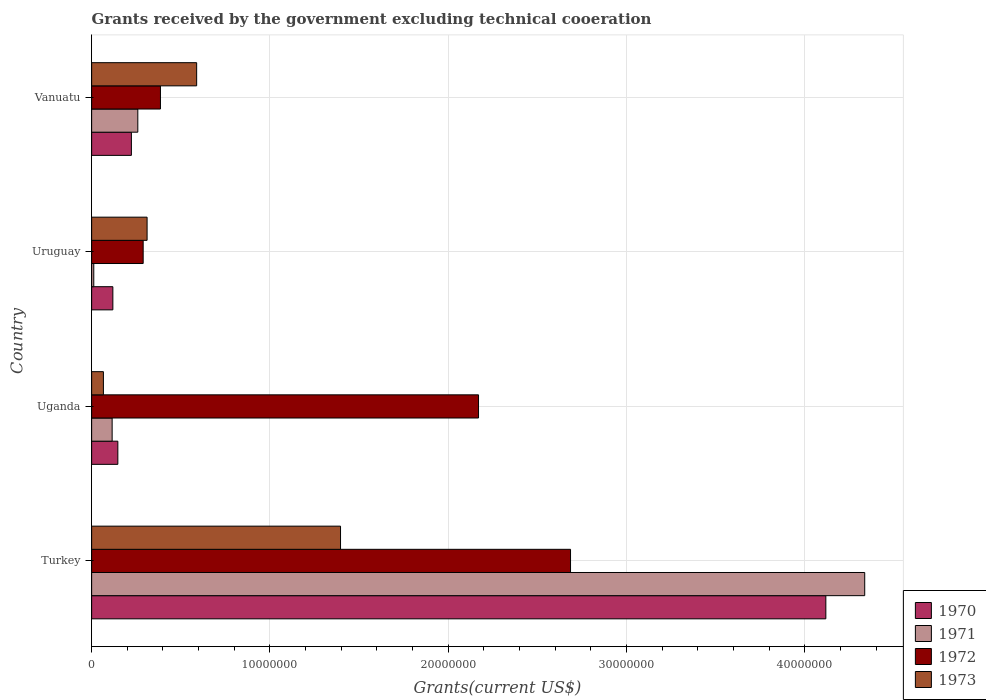How many groups of bars are there?
Offer a very short reply. 4. Are the number of bars per tick equal to the number of legend labels?
Offer a very short reply. Yes. How many bars are there on the 2nd tick from the top?
Your answer should be very brief. 4. In how many cases, is the number of bars for a given country not equal to the number of legend labels?
Give a very brief answer. 0. What is the total grants received by the government in 1973 in Vanuatu?
Keep it short and to the point. 5.89e+06. Across all countries, what is the maximum total grants received by the government in 1971?
Your answer should be compact. 4.34e+07. Across all countries, what is the minimum total grants received by the government in 1970?
Offer a very short reply. 1.19e+06. In which country was the total grants received by the government in 1972 minimum?
Your answer should be very brief. Uruguay. What is the total total grants received by the government in 1973 in the graph?
Provide a short and direct response. 2.36e+07. What is the difference between the total grants received by the government in 1971 in Turkey and that in Uganda?
Provide a short and direct response. 4.22e+07. What is the difference between the total grants received by the government in 1972 in Turkey and the total grants received by the government in 1970 in Vanuatu?
Offer a very short reply. 2.46e+07. What is the average total grants received by the government in 1970 per country?
Ensure brevity in your answer.  1.15e+07. What is the difference between the total grants received by the government in 1972 and total grants received by the government in 1970 in Vanuatu?
Provide a succinct answer. 1.63e+06. In how many countries, is the total grants received by the government in 1973 greater than 40000000 US$?
Provide a succinct answer. 0. What is the ratio of the total grants received by the government in 1973 in Uruguay to that in Vanuatu?
Provide a succinct answer. 0.53. Is the difference between the total grants received by the government in 1972 in Uganda and Vanuatu greater than the difference between the total grants received by the government in 1970 in Uganda and Vanuatu?
Provide a short and direct response. Yes. What is the difference between the highest and the second highest total grants received by the government in 1973?
Keep it short and to the point. 8.07e+06. What is the difference between the highest and the lowest total grants received by the government in 1970?
Offer a very short reply. 4.00e+07. In how many countries, is the total grants received by the government in 1973 greater than the average total grants received by the government in 1973 taken over all countries?
Offer a terse response. 1. Is the sum of the total grants received by the government in 1970 in Uganda and Vanuatu greater than the maximum total grants received by the government in 1971 across all countries?
Offer a terse response. No. What does the 2nd bar from the top in Turkey represents?
Offer a terse response. 1972. Is it the case that in every country, the sum of the total grants received by the government in 1971 and total grants received by the government in 1970 is greater than the total grants received by the government in 1972?
Keep it short and to the point. No. What is the difference between two consecutive major ticks on the X-axis?
Ensure brevity in your answer.  1.00e+07. Where does the legend appear in the graph?
Your response must be concise. Bottom right. How many legend labels are there?
Make the answer very short. 4. How are the legend labels stacked?
Offer a terse response. Vertical. What is the title of the graph?
Keep it short and to the point. Grants received by the government excluding technical cooeration. What is the label or title of the X-axis?
Offer a very short reply. Grants(current US$). What is the label or title of the Y-axis?
Your response must be concise. Country. What is the Grants(current US$) of 1970 in Turkey?
Offer a very short reply. 4.12e+07. What is the Grants(current US$) of 1971 in Turkey?
Your answer should be very brief. 4.34e+07. What is the Grants(current US$) in 1972 in Turkey?
Provide a succinct answer. 2.69e+07. What is the Grants(current US$) in 1973 in Turkey?
Provide a short and direct response. 1.40e+07. What is the Grants(current US$) in 1970 in Uganda?
Your response must be concise. 1.47e+06. What is the Grants(current US$) in 1971 in Uganda?
Ensure brevity in your answer.  1.15e+06. What is the Grants(current US$) of 1972 in Uganda?
Your response must be concise. 2.17e+07. What is the Grants(current US$) of 1973 in Uganda?
Offer a terse response. 6.60e+05. What is the Grants(current US$) in 1970 in Uruguay?
Ensure brevity in your answer.  1.19e+06. What is the Grants(current US$) in 1972 in Uruguay?
Your answer should be compact. 2.89e+06. What is the Grants(current US$) of 1973 in Uruguay?
Make the answer very short. 3.11e+06. What is the Grants(current US$) in 1970 in Vanuatu?
Make the answer very short. 2.23e+06. What is the Grants(current US$) in 1971 in Vanuatu?
Make the answer very short. 2.59e+06. What is the Grants(current US$) in 1972 in Vanuatu?
Make the answer very short. 3.86e+06. What is the Grants(current US$) in 1973 in Vanuatu?
Ensure brevity in your answer.  5.89e+06. Across all countries, what is the maximum Grants(current US$) of 1970?
Make the answer very short. 4.12e+07. Across all countries, what is the maximum Grants(current US$) in 1971?
Provide a succinct answer. 4.34e+07. Across all countries, what is the maximum Grants(current US$) of 1972?
Your answer should be very brief. 2.69e+07. Across all countries, what is the maximum Grants(current US$) in 1973?
Your answer should be compact. 1.40e+07. Across all countries, what is the minimum Grants(current US$) in 1970?
Your response must be concise. 1.19e+06. Across all countries, what is the minimum Grants(current US$) of 1972?
Your answer should be very brief. 2.89e+06. Across all countries, what is the minimum Grants(current US$) of 1973?
Offer a terse response. 6.60e+05. What is the total Grants(current US$) of 1970 in the graph?
Ensure brevity in your answer.  4.61e+07. What is the total Grants(current US$) of 1971 in the graph?
Your answer should be very brief. 4.72e+07. What is the total Grants(current US$) of 1972 in the graph?
Offer a very short reply. 5.53e+07. What is the total Grants(current US$) in 1973 in the graph?
Make the answer very short. 2.36e+07. What is the difference between the Grants(current US$) of 1970 in Turkey and that in Uganda?
Keep it short and to the point. 3.97e+07. What is the difference between the Grants(current US$) in 1971 in Turkey and that in Uganda?
Offer a terse response. 4.22e+07. What is the difference between the Grants(current US$) in 1972 in Turkey and that in Uganda?
Your answer should be very brief. 5.16e+06. What is the difference between the Grants(current US$) in 1973 in Turkey and that in Uganda?
Keep it short and to the point. 1.33e+07. What is the difference between the Grants(current US$) of 1970 in Turkey and that in Uruguay?
Your answer should be very brief. 4.00e+07. What is the difference between the Grants(current US$) of 1971 in Turkey and that in Uruguay?
Your answer should be compact. 4.32e+07. What is the difference between the Grants(current US$) in 1972 in Turkey and that in Uruguay?
Provide a short and direct response. 2.40e+07. What is the difference between the Grants(current US$) of 1973 in Turkey and that in Uruguay?
Your response must be concise. 1.08e+07. What is the difference between the Grants(current US$) of 1970 in Turkey and that in Vanuatu?
Your response must be concise. 3.90e+07. What is the difference between the Grants(current US$) of 1971 in Turkey and that in Vanuatu?
Your answer should be compact. 4.08e+07. What is the difference between the Grants(current US$) in 1972 in Turkey and that in Vanuatu?
Your answer should be compact. 2.30e+07. What is the difference between the Grants(current US$) in 1973 in Turkey and that in Vanuatu?
Keep it short and to the point. 8.07e+06. What is the difference between the Grants(current US$) of 1971 in Uganda and that in Uruguay?
Give a very brief answer. 1.03e+06. What is the difference between the Grants(current US$) of 1972 in Uganda and that in Uruguay?
Provide a succinct answer. 1.88e+07. What is the difference between the Grants(current US$) in 1973 in Uganda and that in Uruguay?
Provide a short and direct response. -2.45e+06. What is the difference between the Grants(current US$) of 1970 in Uganda and that in Vanuatu?
Provide a short and direct response. -7.60e+05. What is the difference between the Grants(current US$) in 1971 in Uganda and that in Vanuatu?
Keep it short and to the point. -1.44e+06. What is the difference between the Grants(current US$) in 1972 in Uganda and that in Vanuatu?
Make the answer very short. 1.78e+07. What is the difference between the Grants(current US$) of 1973 in Uganda and that in Vanuatu?
Offer a very short reply. -5.23e+06. What is the difference between the Grants(current US$) of 1970 in Uruguay and that in Vanuatu?
Provide a succinct answer. -1.04e+06. What is the difference between the Grants(current US$) in 1971 in Uruguay and that in Vanuatu?
Offer a very short reply. -2.47e+06. What is the difference between the Grants(current US$) of 1972 in Uruguay and that in Vanuatu?
Make the answer very short. -9.70e+05. What is the difference between the Grants(current US$) of 1973 in Uruguay and that in Vanuatu?
Provide a succinct answer. -2.78e+06. What is the difference between the Grants(current US$) of 1970 in Turkey and the Grants(current US$) of 1971 in Uganda?
Provide a short and direct response. 4.00e+07. What is the difference between the Grants(current US$) of 1970 in Turkey and the Grants(current US$) of 1972 in Uganda?
Ensure brevity in your answer.  1.95e+07. What is the difference between the Grants(current US$) in 1970 in Turkey and the Grants(current US$) in 1973 in Uganda?
Your response must be concise. 4.05e+07. What is the difference between the Grants(current US$) in 1971 in Turkey and the Grants(current US$) in 1972 in Uganda?
Provide a succinct answer. 2.17e+07. What is the difference between the Grants(current US$) in 1971 in Turkey and the Grants(current US$) in 1973 in Uganda?
Offer a very short reply. 4.27e+07. What is the difference between the Grants(current US$) in 1972 in Turkey and the Grants(current US$) in 1973 in Uganda?
Your answer should be very brief. 2.62e+07. What is the difference between the Grants(current US$) in 1970 in Turkey and the Grants(current US$) in 1971 in Uruguay?
Give a very brief answer. 4.11e+07. What is the difference between the Grants(current US$) in 1970 in Turkey and the Grants(current US$) in 1972 in Uruguay?
Your answer should be very brief. 3.83e+07. What is the difference between the Grants(current US$) in 1970 in Turkey and the Grants(current US$) in 1973 in Uruguay?
Offer a terse response. 3.81e+07. What is the difference between the Grants(current US$) of 1971 in Turkey and the Grants(current US$) of 1972 in Uruguay?
Provide a short and direct response. 4.05e+07. What is the difference between the Grants(current US$) of 1971 in Turkey and the Grants(current US$) of 1973 in Uruguay?
Ensure brevity in your answer.  4.02e+07. What is the difference between the Grants(current US$) of 1972 in Turkey and the Grants(current US$) of 1973 in Uruguay?
Offer a very short reply. 2.38e+07. What is the difference between the Grants(current US$) in 1970 in Turkey and the Grants(current US$) in 1971 in Vanuatu?
Your answer should be very brief. 3.86e+07. What is the difference between the Grants(current US$) in 1970 in Turkey and the Grants(current US$) in 1972 in Vanuatu?
Your answer should be compact. 3.73e+07. What is the difference between the Grants(current US$) in 1970 in Turkey and the Grants(current US$) in 1973 in Vanuatu?
Make the answer very short. 3.53e+07. What is the difference between the Grants(current US$) of 1971 in Turkey and the Grants(current US$) of 1972 in Vanuatu?
Your answer should be compact. 3.95e+07. What is the difference between the Grants(current US$) in 1971 in Turkey and the Grants(current US$) in 1973 in Vanuatu?
Give a very brief answer. 3.75e+07. What is the difference between the Grants(current US$) in 1972 in Turkey and the Grants(current US$) in 1973 in Vanuatu?
Keep it short and to the point. 2.10e+07. What is the difference between the Grants(current US$) of 1970 in Uganda and the Grants(current US$) of 1971 in Uruguay?
Offer a terse response. 1.35e+06. What is the difference between the Grants(current US$) in 1970 in Uganda and the Grants(current US$) in 1972 in Uruguay?
Your answer should be very brief. -1.42e+06. What is the difference between the Grants(current US$) in 1970 in Uganda and the Grants(current US$) in 1973 in Uruguay?
Give a very brief answer. -1.64e+06. What is the difference between the Grants(current US$) of 1971 in Uganda and the Grants(current US$) of 1972 in Uruguay?
Keep it short and to the point. -1.74e+06. What is the difference between the Grants(current US$) in 1971 in Uganda and the Grants(current US$) in 1973 in Uruguay?
Keep it short and to the point. -1.96e+06. What is the difference between the Grants(current US$) of 1972 in Uganda and the Grants(current US$) of 1973 in Uruguay?
Make the answer very short. 1.86e+07. What is the difference between the Grants(current US$) in 1970 in Uganda and the Grants(current US$) in 1971 in Vanuatu?
Offer a terse response. -1.12e+06. What is the difference between the Grants(current US$) of 1970 in Uganda and the Grants(current US$) of 1972 in Vanuatu?
Make the answer very short. -2.39e+06. What is the difference between the Grants(current US$) in 1970 in Uganda and the Grants(current US$) in 1973 in Vanuatu?
Your answer should be very brief. -4.42e+06. What is the difference between the Grants(current US$) of 1971 in Uganda and the Grants(current US$) of 1972 in Vanuatu?
Ensure brevity in your answer.  -2.71e+06. What is the difference between the Grants(current US$) of 1971 in Uganda and the Grants(current US$) of 1973 in Vanuatu?
Your answer should be compact. -4.74e+06. What is the difference between the Grants(current US$) in 1972 in Uganda and the Grants(current US$) in 1973 in Vanuatu?
Keep it short and to the point. 1.58e+07. What is the difference between the Grants(current US$) of 1970 in Uruguay and the Grants(current US$) of 1971 in Vanuatu?
Provide a short and direct response. -1.40e+06. What is the difference between the Grants(current US$) of 1970 in Uruguay and the Grants(current US$) of 1972 in Vanuatu?
Give a very brief answer. -2.67e+06. What is the difference between the Grants(current US$) of 1970 in Uruguay and the Grants(current US$) of 1973 in Vanuatu?
Keep it short and to the point. -4.70e+06. What is the difference between the Grants(current US$) of 1971 in Uruguay and the Grants(current US$) of 1972 in Vanuatu?
Ensure brevity in your answer.  -3.74e+06. What is the difference between the Grants(current US$) of 1971 in Uruguay and the Grants(current US$) of 1973 in Vanuatu?
Offer a terse response. -5.77e+06. What is the difference between the Grants(current US$) in 1972 in Uruguay and the Grants(current US$) in 1973 in Vanuatu?
Provide a succinct answer. -3.00e+06. What is the average Grants(current US$) of 1970 per country?
Give a very brief answer. 1.15e+07. What is the average Grants(current US$) in 1971 per country?
Give a very brief answer. 1.18e+07. What is the average Grants(current US$) in 1972 per country?
Offer a very short reply. 1.38e+07. What is the average Grants(current US$) of 1973 per country?
Offer a terse response. 5.90e+06. What is the difference between the Grants(current US$) in 1970 and Grants(current US$) in 1971 in Turkey?
Offer a terse response. -2.18e+06. What is the difference between the Grants(current US$) of 1970 and Grants(current US$) of 1972 in Turkey?
Offer a terse response. 1.43e+07. What is the difference between the Grants(current US$) in 1970 and Grants(current US$) in 1973 in Turkey?
Provide a succinct answer. 2.72e+07. What is the difference between the Grants(current US$) in 1971 and Grants(current US$) in 1972 in Turkey?
Give a very brief answer. 1.65e+07. What is the difference between the Grants(current US$) in 1971 and Grants(current US$) in 1973 in Turkey?
Ensure brevity in your answer.  2.94e+07. What is the difference between the Grants(current US$) in 1972 and Grants(current US$) in 1973 in Turkey?
Your answer should be compact. 1.29e+07. What is the difference between the Grants(current US$) in 1970 and Grants(current US$) in 1971 in Uganda?
Provide a short and direct response. 3.20e+05. What is the difference between the Grants(current US$) in 1970 and Grants(current US$) in 1972 in Uganda?
Your response must be concise. -2.02e+07. What is the difference between the Grants(current US$) of 1970 and Grants(current US$) of 1973 in Uganda?
Your answer should be compact. 8.10e+05. What is the difference between the Grants(current US$) of 1971 and Grants(current US$) of 1972 in Uganda?
Your answer should be very brief. -2.06e+07. What is the difference between the Grants(current US$) in 1972 and Grants(current US$) in 1973 in Uganda?
Your answer should be compact. 2.10e+07. What is the difference between the Grants(current US$) in 1970 and Grants(current US$) in 1971 in Uruguay?
Provide a succinct answer. 1.07e+06. What is the difference between the Grants(current US$) of 1970 and Grants(current US$) of 1972 in Uruguay?
Your answer should be compact. -1.70e+06. What is the difference between the Grants(current US$) of 1970 and Grants(current US$) of 1973 in Uruguay?
Provide a short and direct response. -1.92e+06. What is the difference between the Grants(current US$) in 1971 and Grants(current US$) in 1972 in Uruguay?
Your answer should be compact. -2.77e+06. What is the difference between the Grants(current US$) in 1971 and Grants(current US$) in 1973 in Uruguay?
Your answer should be compact. -2.99e+06. What is the difference between the Grants(current US$) in 1970 and Grants(current US$) in 1971 in Vanuatu?
Give a very brief answer. -3.60e+05. What is the difference between the Grants(current US$) in 1970 and Grants(current US$) in 1972 in Vanuatu?
Your response must be concise. -1.63e+06. What is the difference between the Grants(current US$) of 1970 and Grants(current US$) of 1973 in Vanuatu?
Your response must be concise. -3.66e+06. What is the difference between the Grants(current US$) of 1971 and Grants(current US$) of 1972 in Vanuatu?
Make the answer very short. -1.27e+06. What is the difference between the Grants(current US$) of 1971 and Grants(current US$) of 1973 in Vanuatu?
Provide a succinct answer. -3.30e+06. What is the difference between the Grants(current US$) of 1972 and Grants(current US$) of 1973 in Vanuatu?
Give a very brief answer. -2.03e+06. What is the ratio of the Grants(current US$) of 1970 in Turkey to that in Uganda?
Give a very brief answer. 28.01. What is the ratio of the Grants(current US$) of 1971 in Turkey to that in Uganda?
Your answer should be very brief. 37.7. What is the ratio of the Grants(current US$) of 1972 in Turkey to that in Uganda?
Ensure brevity in your answer.  1.24. What is the ratio of the Grants(current US$) of 1973 in Turkey to that in Uganda?
Offer a terse response. 21.15. What is the ratio of the Grants(current US$) of 1970 in Turkey to that in Uruguay?
Provide a succinct answer. 34.6. What is the ratio of the Grants(current US$) of 1971 in Turkey to that in Uruguay?
Provide a short and direct response. 361.33. What is the ratio of the Grants(current US$) of 1972 in Turkey to that in Uruguay?
Offer a terse response. 9.29. What is the ratio of the Grants(current US$) of 1973 in Turkey to that in Uruguay?
Your answer should be very brief. 4.49. What is the ratio of the Grants(current US$) of 1970 in Turkey to that in Vanuatu?
Your answer should be compact. 18.47. What is the ratio of the Grants(current US$) of 1971 in Turkey to that in Vanuatu?
Your answer should be very brief. 16.74. What is the ratio of the Grants(current US$) of 1972 in Turkey to that in Vanuatu?
Ensure brevity in your answer.  6.96. What is the ratio of the Grants(current US$) of 1973 in Turkey to that in Vanuatu?
Ensure brevity in your answer.  2.37. What is the ratio of the Grants(current US$) in 1970 in Uganda to that in Uruguay?
Provide a succinct answer. 1.24. What is the ratio of the Grants(current US$) in 1971 in Uganda to that in Uruguay?
Your answer should be very brief. 9.58. What is the ratio of the Grants(current US$) in 1972 in Uganda to that in Uruguay?
Give a very brief answer. 7.51. What is the ratio of the Grants(current US$) in 1973 in Uganda to that in Uruguay?
Your response must be concise. 0.21. What is the ratio of the Grants(current US$) of 1970 in Uganda to that in Vanuatu?
Your answer should be compact. 0.66. What is the ratio of the Grants(current US$) in 1971 in Uganda to that in Vanuatu?
Offer a terse response. 0.44. What is the ratio of the Grants(current US$) of 1972 in Uganda to that in Vanuatu?
Your answer should be compact. 5.62. What is the ratio of the Grants(current US$) of 1973 in Uganda to that in Vanuatu?
Provide a succinct answer. 0.11. What is the ratio of the Grants(current US$) in 1970 in Uruguay to that in Vanuatu?
Make the answer very short. 0.53. What is the ratio of the Grants(current US$) in 1971 in Uruguay to that in Vanuatu?
Your answer should be very brief. 0.05. What is the ratio of the Grants(current US$) in 1972 in Uruguay to that in Vanuatu?
Keep it short and to the point. 0.75. What is the ratio of the Grants(current US$) of 1973 in Uruguay to that in Vanuatu?
Your answer should be compact. 0.53. What is the difference between the highest and the second highest Grants(current US$) in 1970?
Your answer should be compact. 3.90e+07. What is the difference between the highest and the second highest Grants(current US$) of 1971?
Give a very brief answer. 4.08e+07. What is the difference between the highest and the second highest Grants(current US$) of 1972?
Make the answer very short. 5.16e+06. What is the difference between the highest and the second highest Grants(current US$) in 1973?
Ensure brevity in your answer.  8.07e+06. What is the difference between the highest and the lowest Grants(current US$) in 1970?
Your answer should be very brief. 4.00e+07. What is the difference between the highest and the lowest Grants(current US$) of 1971?
Offer a very short reply. 4.32e+07. What is the difference between the highest and the lowest Grants(current US$) in 1972?
Your answer should be very brief. 2.40e+07. What is the difference between the highest and the lowest Grants(current US$) of 1973?
Offer a terse response. 1.33e+07. 